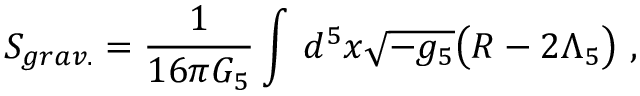<formula> <loc_0><loc_0><loc_500><loc_500>S _ { g r a v . } = \frac { 1 } { 1 6 \pi G _ { 5 } } \int \, d ^ { 5 } x \sqrt { - g _ { 5 } } \left ( R - 2 \Lambda _ { 5 } \right ) \ ,</formula> 